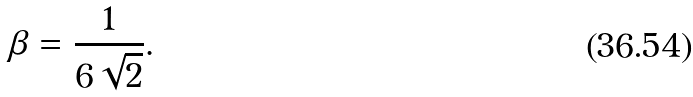Convert formula to latex. <formula><loc_0><loc_0><loc_500><loc_500>\beta = \frac { 1 } { 6 \sqrt { 2 } } .</formula> 